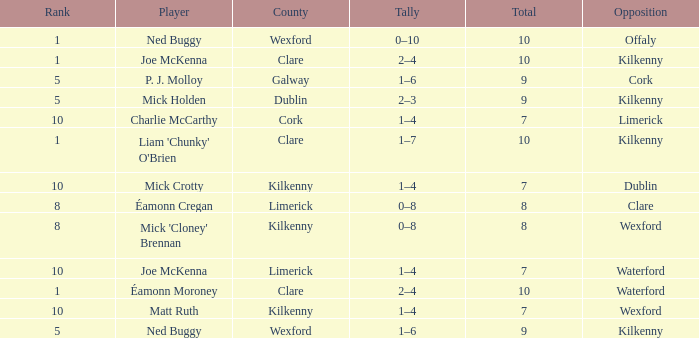Help me parse the entirety of this table. {'header': ['Rank', 'Player', 'County', 'Tally', 'Total', 'Opposition'], 'rows': [['1', 'Ned Buggy', 'Wexford', '0–10', '10', 'Offaly'], ['1', 'Joe McKenna', 'Clare', '2–4', '10', 'Kilkenny'], ['5', 'P. J. Molloy', 'Galway', '1–6', '9', 'Cork'], ['5', 'Mick Holden', 'Dublin', '2–3', '9', 'Kilkenny'], ['10', 'Charlie McCarthy', 'Cork', '1–4', '7', 'Limerick'], ['1', "Liam 'Chunky' O'Brien", 'Clare', '1–7', '10', 'Kilkenny'], ['10', 'Mick Crotty', 'Kilkenny', '1–4', '7', 'Dublin'], ['8', 'Éamonn Cregan', 'Limerick', '0–8', '8', 'Clare'], ['8', "Mick 'Cloney' Brennan", 'Kilkenny', '0–8', '8', 'Wexford'], ['10', 'Joe McKenna', 'Limerick', '1–4', '7', 'Waterford'], ['1', 'Éamonn Moroney', 'Clare', '2–4', '10', 'Waterford'], ['10', 'Matt Ruth', 'Kilkenny', '1–4', '7', 'Wexford'], ['5', 'Ned Buggy', 'Wexford', '1–6', '9', 'Kilkenny']]} Which County has a Rank larger than 8, and a Player of joe mckenna? Limerick. 